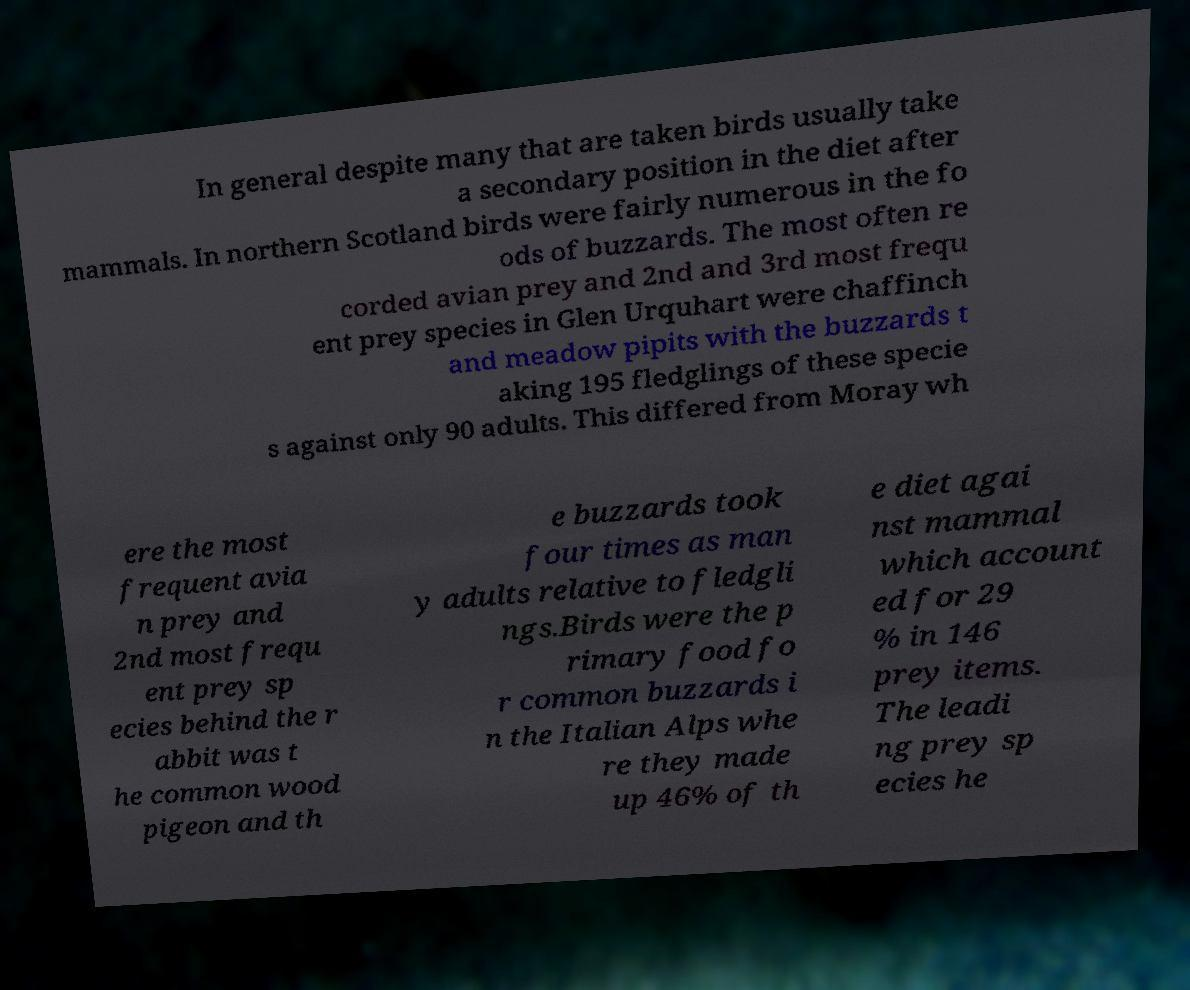Can you read and provide the text displayed in the image?This photo seems to have some interesting text. Can you extract and type it out for me? In general despite many that are taken birds usually take a secondary position in the diet after mammals. In northern Scotland birds were fairly numerous in the fo ods of buzzards. The most often re corded avian prey and 2nd and 3rd most frequ ent prey species in Glen Urquhart were chaffinch and meadow pipits with the buzzards t aking 195 fledglings of these specie s against only 90 adults. This differed from Moray wh ere the most frequent avia n prey and 2nd most frequ ent prey sp ecies behind the r abbit was t he common wood pigeon and th e buzzards took four times as man y adults relative to fledgli ngs.Birds were the p rimary food fo r common buzzards i n the Italian Alps whe re they made up 46% of th e diet agai nst mammal which account ed for 29 % in 146 prey items. The leadi ng prey sp ecies he 